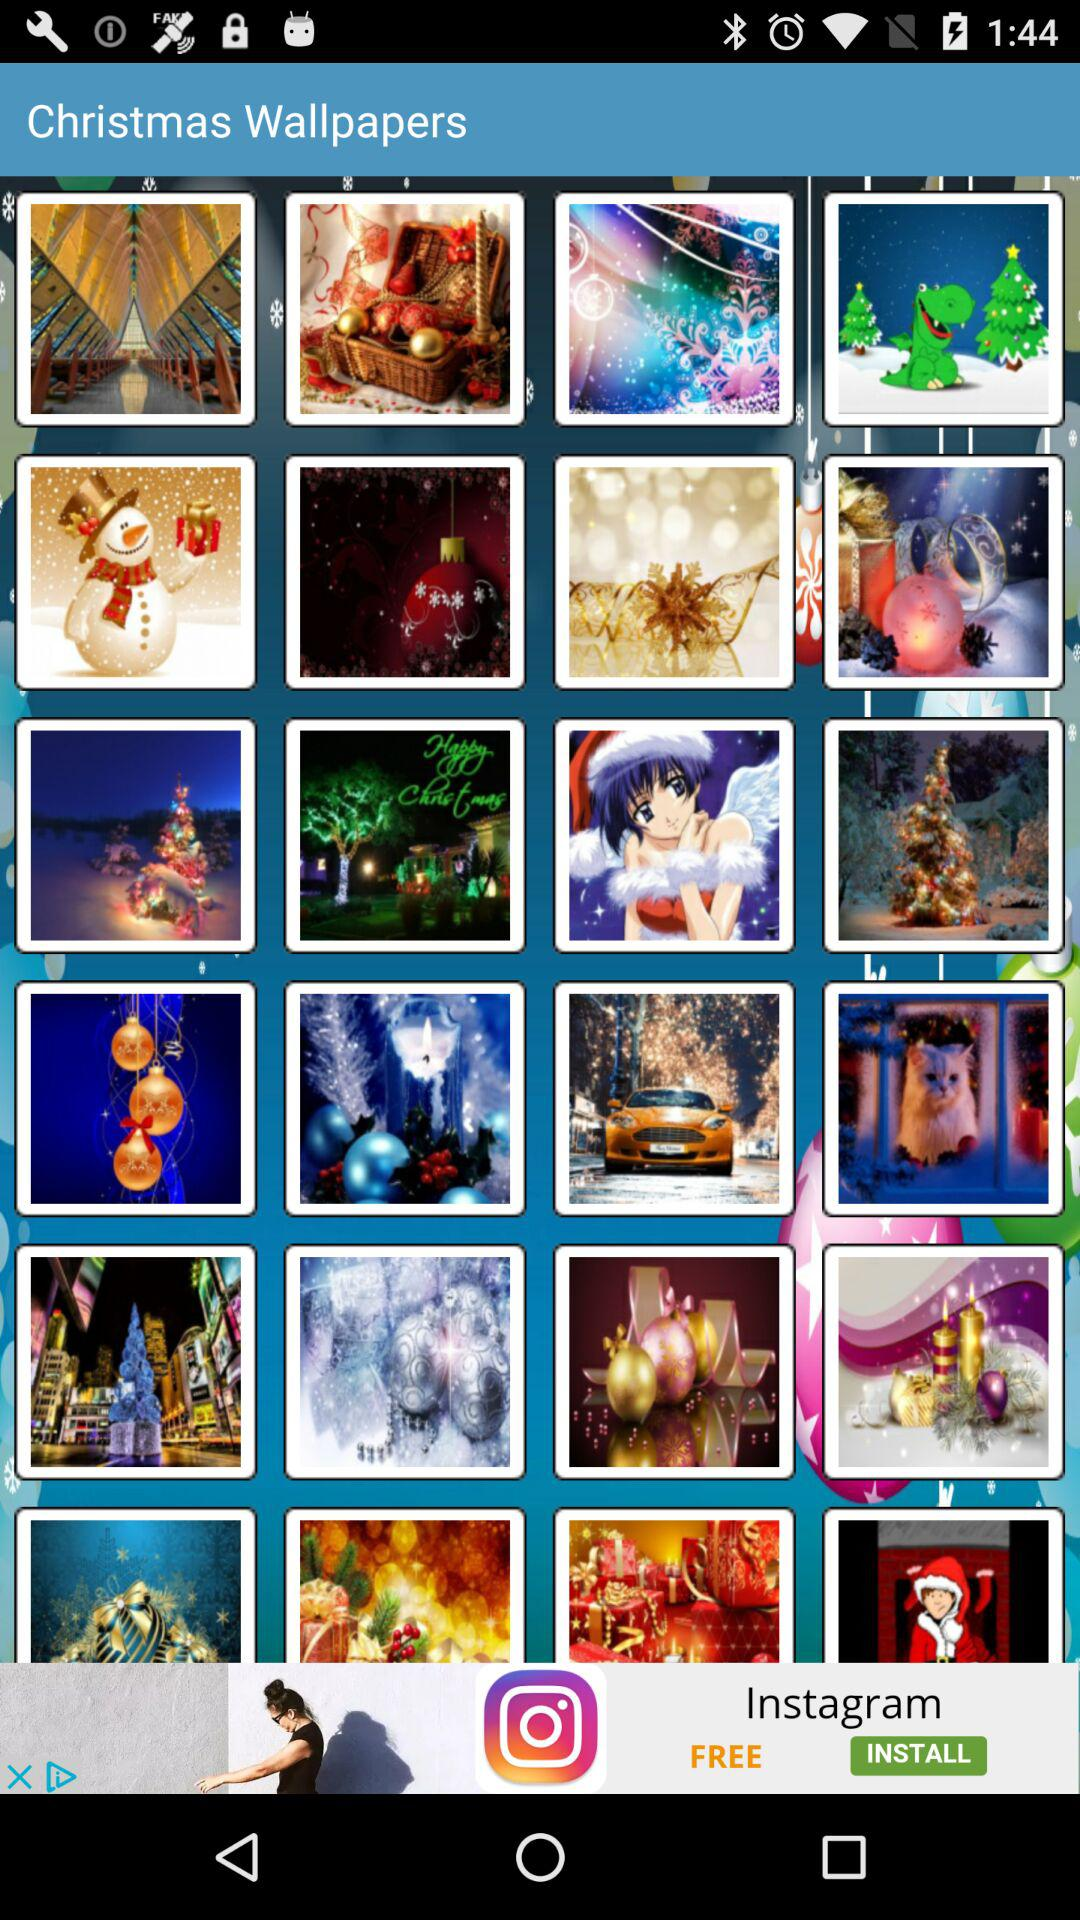What is the application name? The application name is "Christmas Wallpapers". 